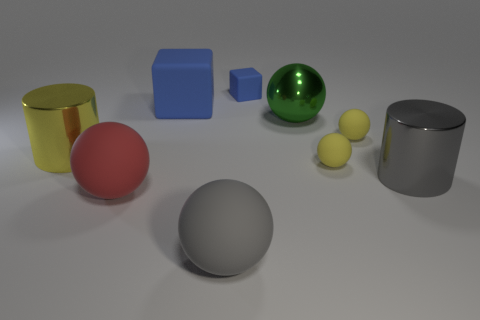Subtract all red balls. How many balls are left? 4 Subtract all green spheres. How many spheres are left? 4 Subtract 3 balls. How many balls are left? 2 Subtract all gray spheres. Subtract all brown cylinders. How many spheres are left? 4 Add 1 small green rubber objects. How many objects exist? 10 Subtract all cylinders. How many objects are left? 7 Subtract 0 brown cubes. How many objects are left? 9 Subtract all big purple metal things. Subtract all big green shiny objects. How many objects are left? 8 Add 7 big matte blocks. How many big matte blocks are left? 8 Add 8 tiny purple metallic spheres. How many tiny purple metallic spheres exist? 8 